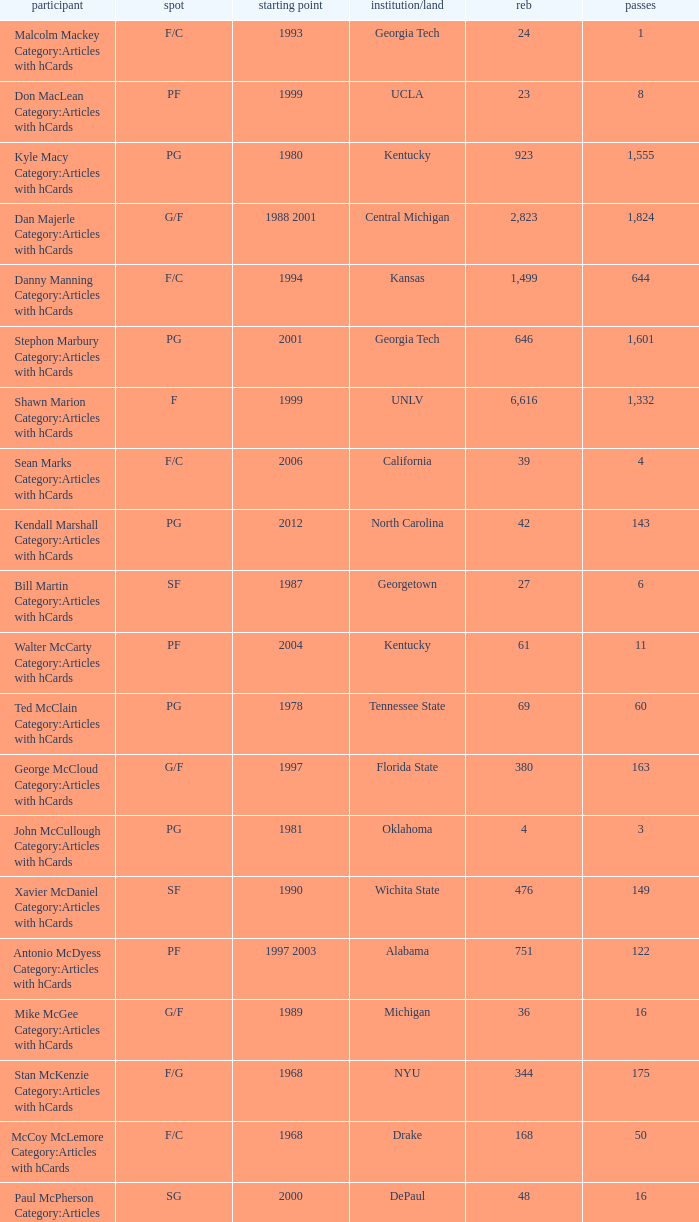Who has the high assists in 2000? 16.0. 